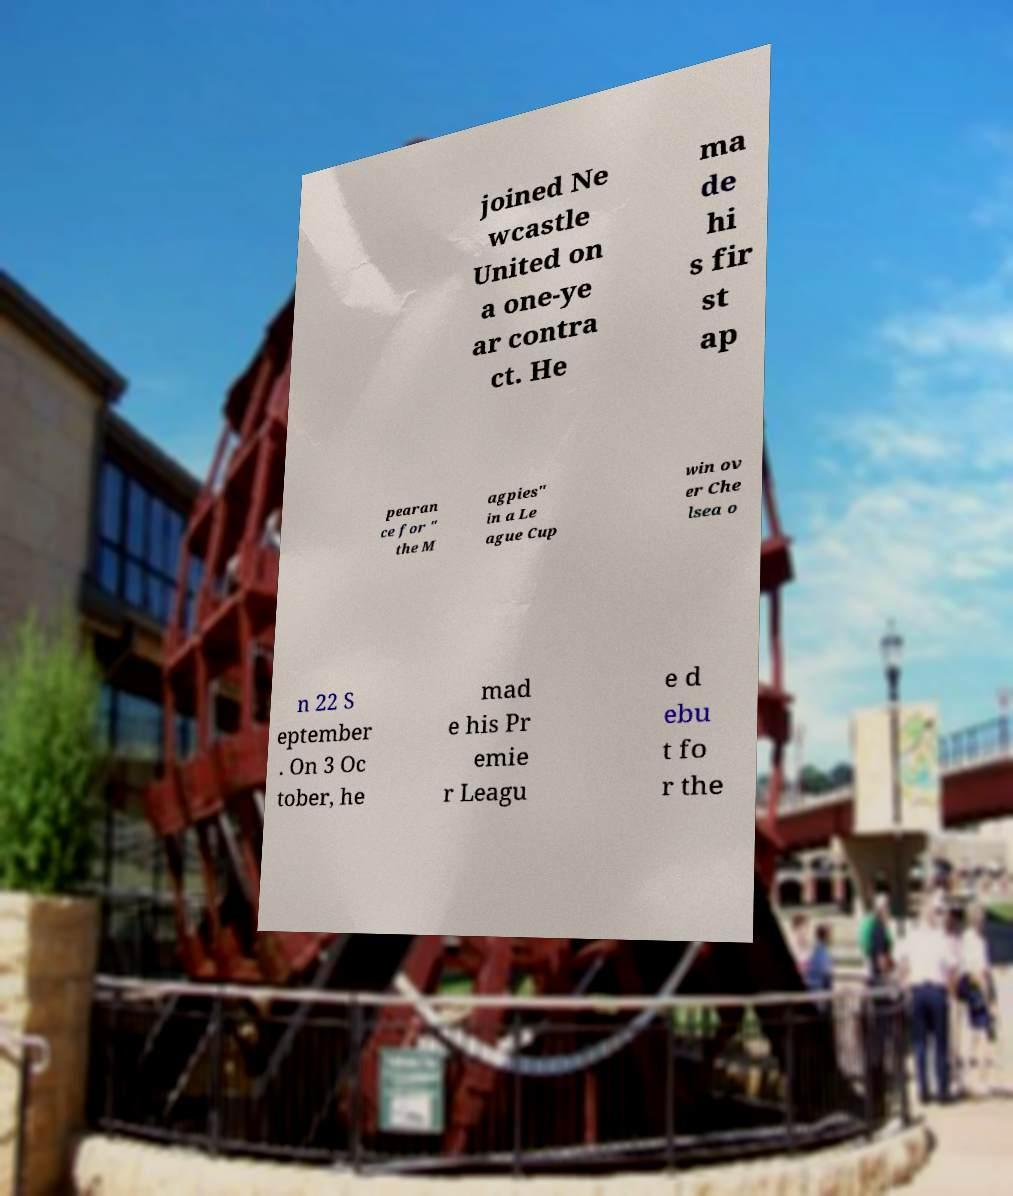Can you accurately transcribe the text from the provided image for me? joined Ne wcastle United on a one-ye ar contra ct. He ma de hi s fir st ap pearan ce for " the M agpies" in a Le ague Cup win ov er Che lsea o n 22 S eptember . On 3 Oc tober, he mad e his Pr emie r Leagu e d ebu t fo r the 